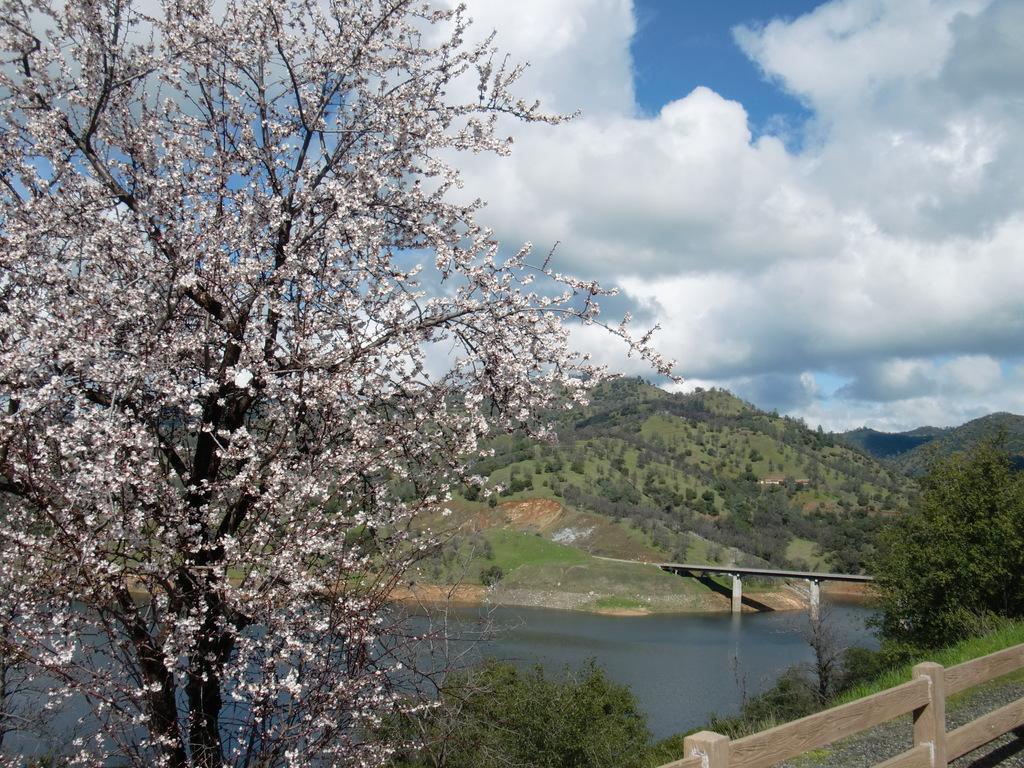Describe this image in one or two sentences. In the picture I can see a tree which has white flowers on it in the left corner and there is water,bridge,mountains and trees in the background. 